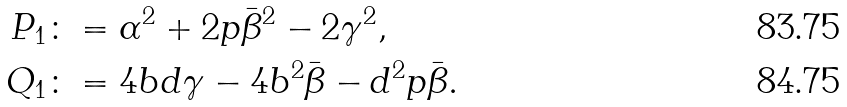Convert formula to latex. <formula><loc_0><loc_0><loc_500><loc_500>P _ { 1 } & \colon = \alpha ^ { 2 } + 2 p \bar { \beta } ^ { 2 } - 2 \gamma ^ { 2 } , \\ Q _ { 1 } & \colon = 4 b d \gamma - 4 b ^ { 2 } \bar { \beta } - d ^ { 2 } p \bar { \beta } .</formula> 